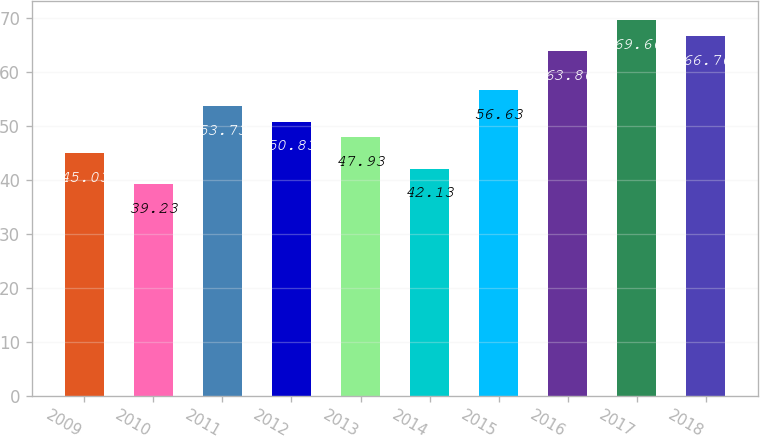<chart> <loc_0><loc_0><loc_500><loc_500><bar_chart><fcel>2009<fcel>2010<fcel>2011<fcel>2012<fcel>2013<fcel>2014<fcel>2015<fcel>2016<fcel>2017<fcel>2018<nl><fcel>45.03<fcel>39.23<fcel>53.73<fcel>50.83<fcel>47.93<fcel>42.13<fcel>56.63<fcel>63.86<fcel>69.66<fcel>66.76<nl></chart> 